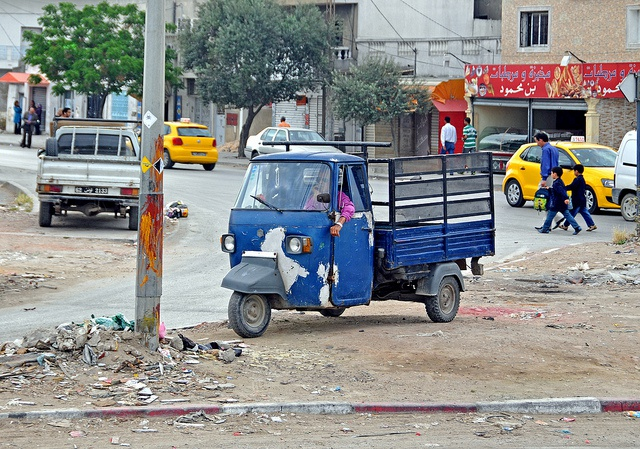Describe the objects in this image and their specific colors. I can see truck in darkgray, black, blue, navy, and gray tones, truck in darkgray, black, gray, and lightblue tones, car in darkgray, orange, gold, gray, and black tones, car in darkgray, orange, gray, gold, and black tones, and car in darkgray, lightgray, gray, and black tones in this image. 